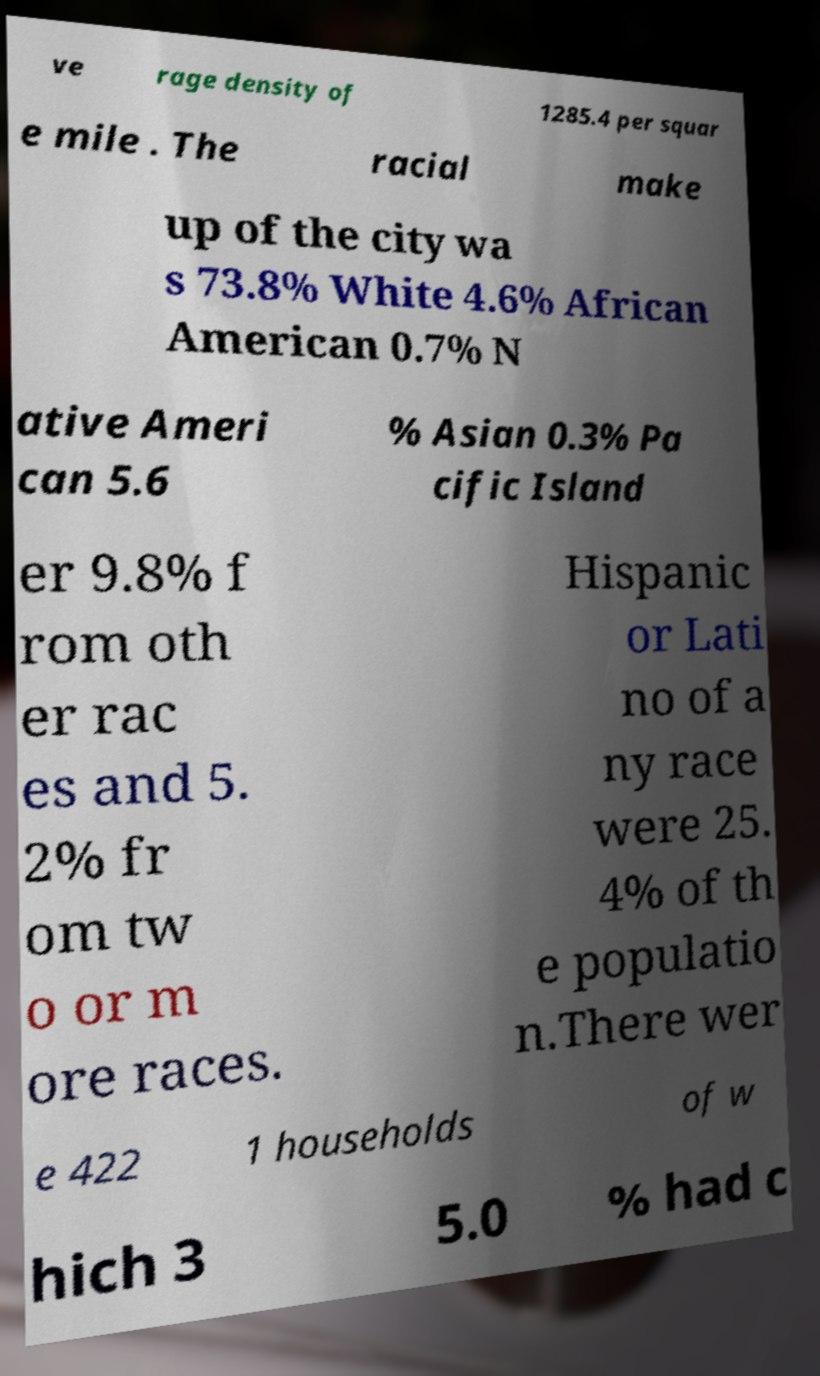Can you read and provide the text displayed in the image?This photo seems to have some interesting text. Can you extract and type it out for me? ve rage density of 1285.4 per squar e mile . The racial make up of the city wa s 73.8% White 4.6% African American 0.7% N ative Ameri can 5.6 % Asian 0.3% Pa cific Island er 9.8% f rom oth er rac es and 5. 2% fr om tw o or m ore races. Hispanic or Lati no of a ny race were 25. 4% of th e populatio n.There wer e 422 1 households of w hich 3 5.0 % had c 